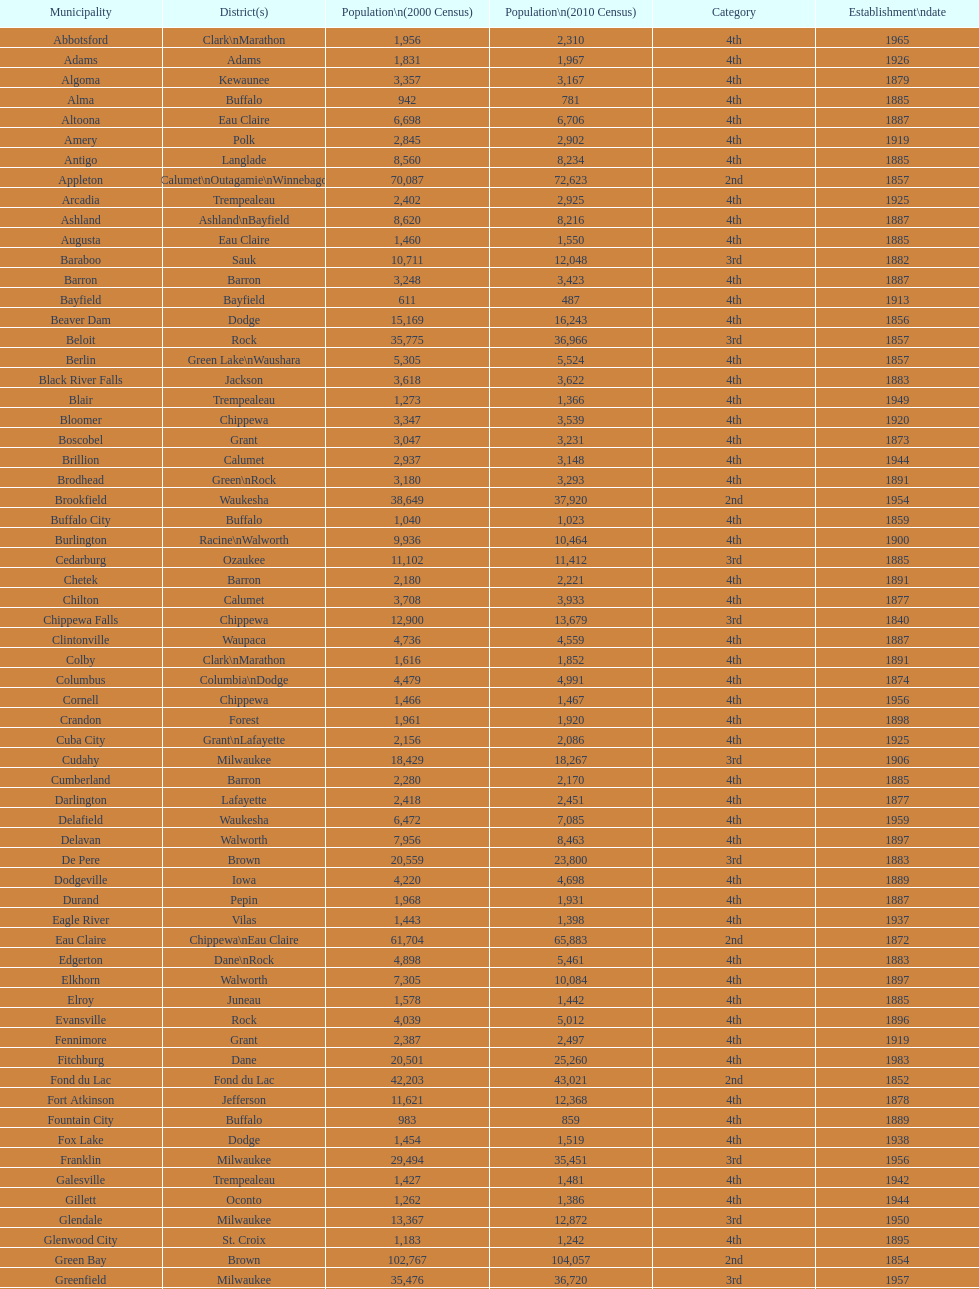How many cities have 1926 as their incorporation date? 2. 